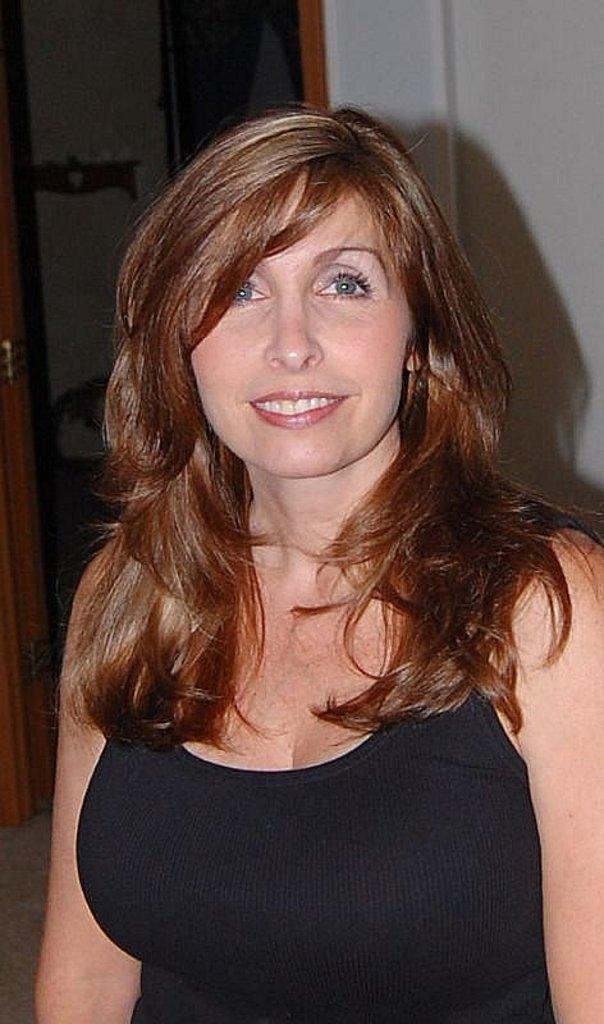Please provide a concise description of this image. In this image I can see a person and the person is wearing black color dress. Background the wall is in white color. 